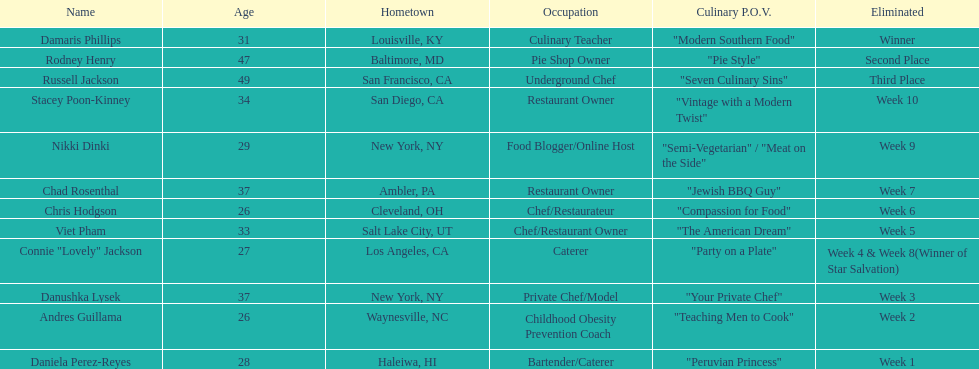Which competitor only lasted two weeks? Andres Guillama. 